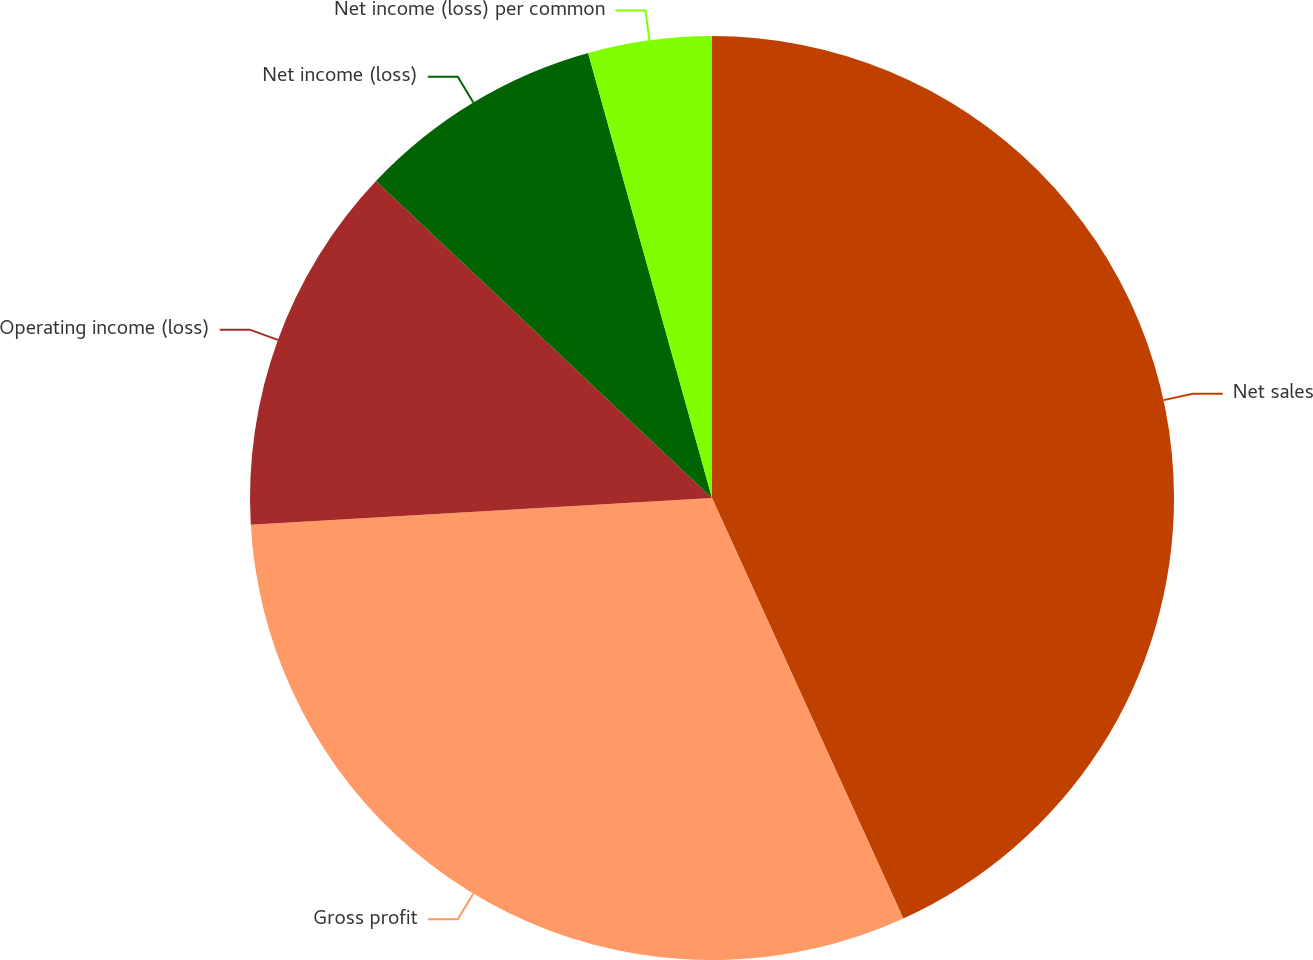Convert chart to OTSL. <chart><loc_0><loc_0><loc_500><loc_500><pie_chart><fcel>Net sales<fcel>Gross profit<fcel>Operating income (loss)<fcel>Net income (loss)<fcel>Net income (loss) per common<nl><fcel>43.2%<fcel>30.87%<fcel>12.96%<fcel>8.64%<fcel>4.32%<nl></chart> 